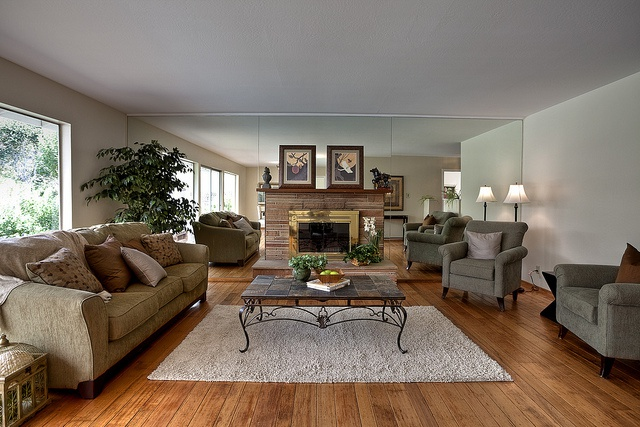Describe the objects in this image and their specific colors. I can see couch in gray, maroon, black, and darkgray tones, chair in gray and black tones, potted plant in gray, black, darkgreen, and white tones, chair in gray and black tones, and couch in gray and black tones in this image. 